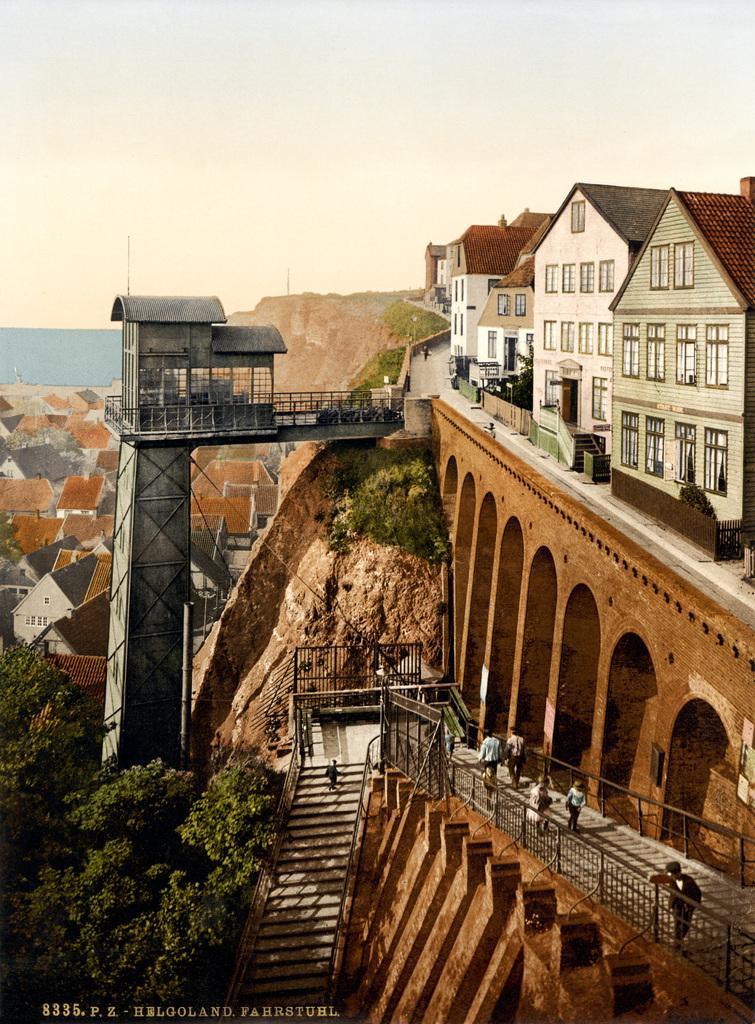Can you describe this image briefly? In this image there are buildings. At the bottom there are trees and we can see a bridge. There are people walking. We can see stairs. In the background there are hills and sky. 